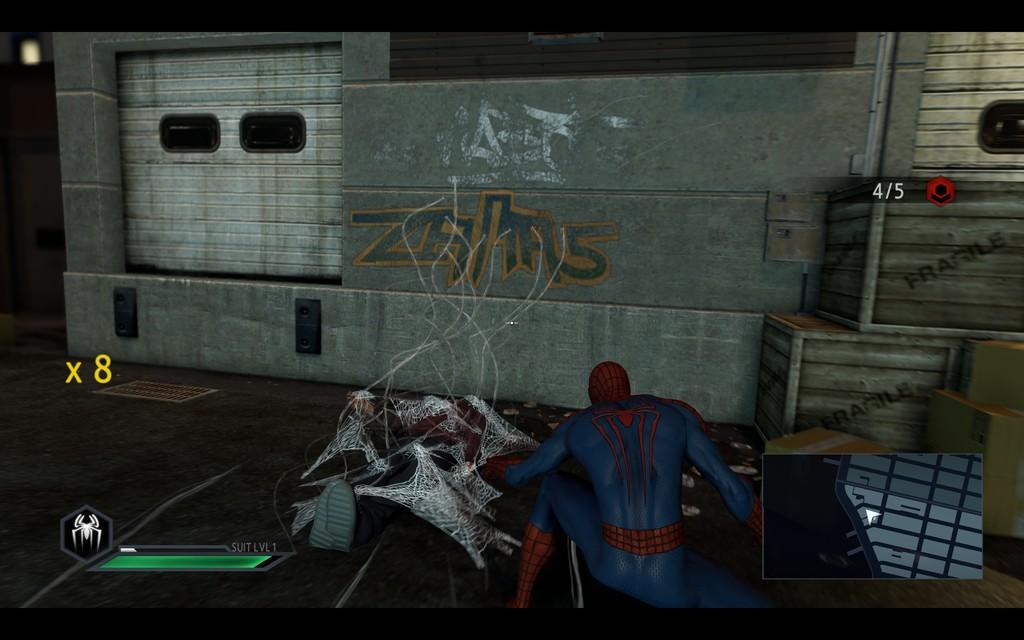What is the main subject of the image? The main subject of the image is a train. What else can be seen in the image besides the train? There are boxes and Spider-Man present in the image. What type of memory is being discussed in the image? There is no discussion or memory present in the image; it features a train, boxes, and Spider-Man. 